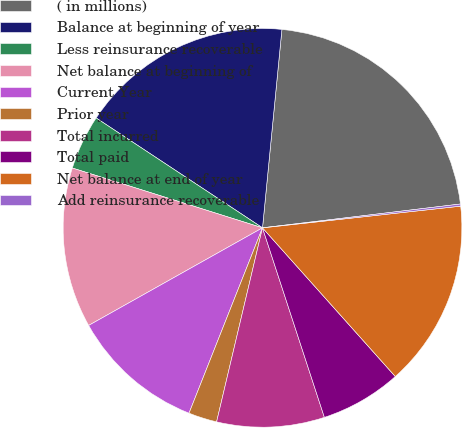<chart> <loc_0><loc_0><loc_500><loc_500><pie_chart><fcel>( in millions)<fcel>Balance at beginning of year<fcel>Less reinsurance recoverable<fcel>Net balance at beginning of<fcel>Current Year<fcel>Prior year<fcel>Total incurred<fcel>Total paid<fcel>Net balance at end of year<fcel>Add reinsurance recoverable<nl><fcel>21.54%<fcel>17.26%<fcel>4.44%<fcel>12.99%<fcel>10.85%<fcel>2.31%<fcel>8.72%<fcel>6.58%<fcel>15.13%<fcel>0.17%<nl></chart> 